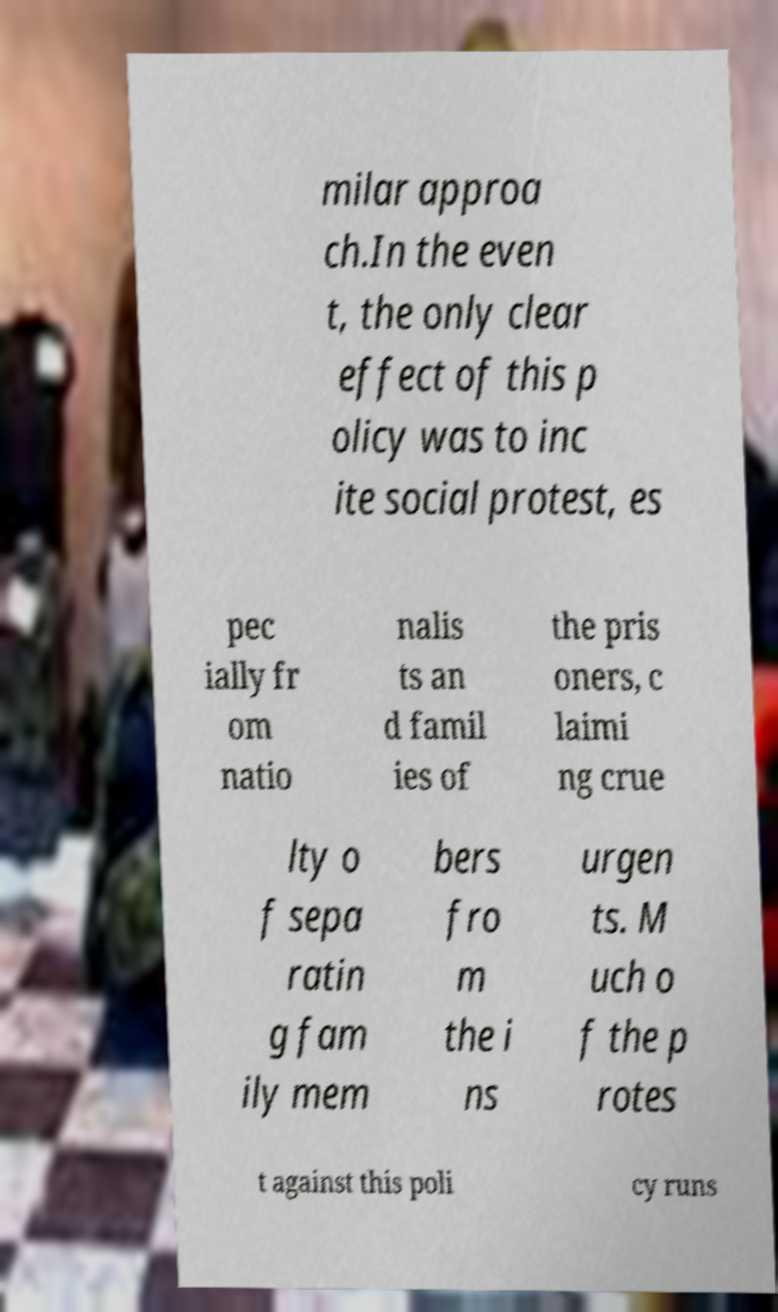Could you extract and type out the text from this image? milar approa ch.In the even t, the only clear effect of this p olicy was to inc ite social protest, es pec ially fr om natio nalis ts an d famil ies of the pris oners, c laimi ng crue lty o f sepa ratin g fam ily mem bers fro m the i ns urgen ts. M uch o f the p rotes t against this poli cy runs 